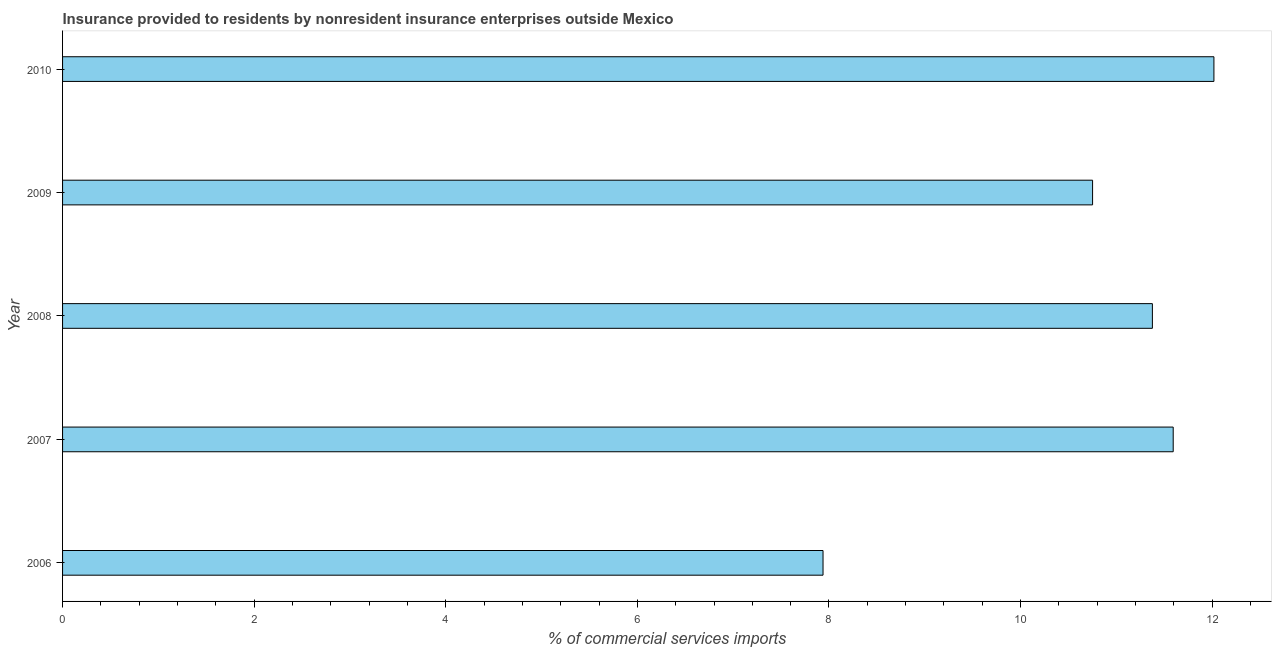Does the graph contain any zero values?
Keep it short and to the point. No. Does the graph contain grids?
Keep it short and to the point. No. What is the title of the graph?
Your response must be concise. Insurance provided to residents by nonresident insurance enterprises outside Mexico. What is the label or title of the X-axis?
Give a very brief answer. % of commercial services imports. What is the insurance provided by non-residents in 2008?
Give a very brief answer. 11.38. Across all years, what is the maximum insurance provided by non-residents?
Provide a succinct answer. 12.02. Across all years, what is the minimum insurance provided by non-residents?
Make the answer very short. 7.94. What is the sum of the insurance provided by non-residents?
Offer a terse response. 53.68. What is the difference between the insurance provided by non-residents in 2007 and 2009?
Make the answer very short. 0.84. What is the average insurance provided by non-residents per year?
Offer a terse response. 10.73. What is the median insurance provided by non-residents?
Offer a terse response. 11.38. Do a majority of the years between 2008 and 2007 (inclusive) have insurance provided by non-residents greater than 5.6 %?
Ensure brevity in your answer.  No. What is the ratio of the insurance provided by non-residents in 2008 to that in 2010?
Provide a short and direct response. 0.95. Is the insurance provided by non-residents in 2008 less than that in 2010?
Your answer should be very brief. Yes. What is the difference between the highest and the second highest insurance provided by non-residents?
Offer a very short reply. 0.42. Is the sum of the insurance provided by non-residents in 2008 and 2009 greater than the maximum insurance provided by non-residents across all years?
Offer a terse response. Yes. What is the difference between the highest and the lowest insurance provided by non-residents?
Your answer should be compact. 4.08. In how many years, is the insurance provided by non-residents greater than the average insurance provided by non-residents taken over all years?
Make the answer very short. 4. Are all the bars in the graph horizontal?
Offer a very short reply. Yes. How many years are there in the graph?
Offer a terse response. 5. What is the difference between two consecutive major ticks on the X-axis?
Provide a succinct answer. 2. What is the % of commercial services imports in 2006?
Ensure brevity in your answer.  7.94. What is the % of commercial services imports of 2007?
Provide a succinct answer. 11.59. What is the % of commercial services imports of 2008?
Your answer should be compact. 11.38. What is the % of commercial services imports in 2009?
Make the answer very short. 10.75. What is the % of commercial services imports in 2010?
Your answer should be compact. 12.02. What is the difference between the % of commercial services imports in 2006 and 2007?
Your response must be concise. -3.66. What is the difference between the % of commercial services imports in 2006 and 2008?
Give a very brief answer. -3.44. What is the difference between the % of commercial services imports in 2006 and 2009?
Your answer should be very brief. -2.81. What is the difference between the % of commercial services imports in 2006 and 2010?
Your answer should be very brief. -4.08. What is the difference between the % of commercial services imports in 2007 and 2008?
Give a very brief answer. 0.22. What is the difference between the % of commercial services imports in 2007 and 2009?
Offer a very short reply. 0.84. What is the difference between the % of commercial services imports in 2007 and 2010?
Offer a very short reply. -0.42. What is the difference between the % of commercial services imports in 2008 and 2009?
Keep it short and to the point. 0.62. What is the difference between the % of commercial services imports in 2008 and 2010?
Provide a succinct answer. -0.64. What is the difference between the % of commercial services imports in 2009 and 2010?
Your answer should be compact. -1.27. What is the ratio of the % of commercial services imports in 2006 to that in 2007?
Provide a succinct answer. 0.69. What is the ratio of the % of commercial services imports in 2006 to that in 2008?
Make the answer very short. 0.7. What is the ratio of the % of commercial services imports in 2006 to that in 2009?
Keep it short and to the point. 0.74. What is the ratio of the % of commercial services imports in 2006 to that in 2010?
Offer a very short reply. 0.66. What is the ratio of the % of commercial services imports in 2007 to that in 2008?
Offer a very short reply. 1.02. What is the ratio of the % of commercial services imports in 2007 to that in 2009?
Give a very brief answer. 1.08. What is the ratio of the % of commercial services imports in 2007 to that in 2010?
Make the answer very short. 0.96. What is the ratio of the % of commercial services imports in 2008 to that in 2009?
Provide a succinct answer. 1.06. What is the ratio of the % of commercial services imports in 2008 to that in 2010?
Your answer should be very brief. 0.95. What is the ratio of the % of commercial services imports in 2009 to that in 2010?
Give a very brief answer. 0.9. 